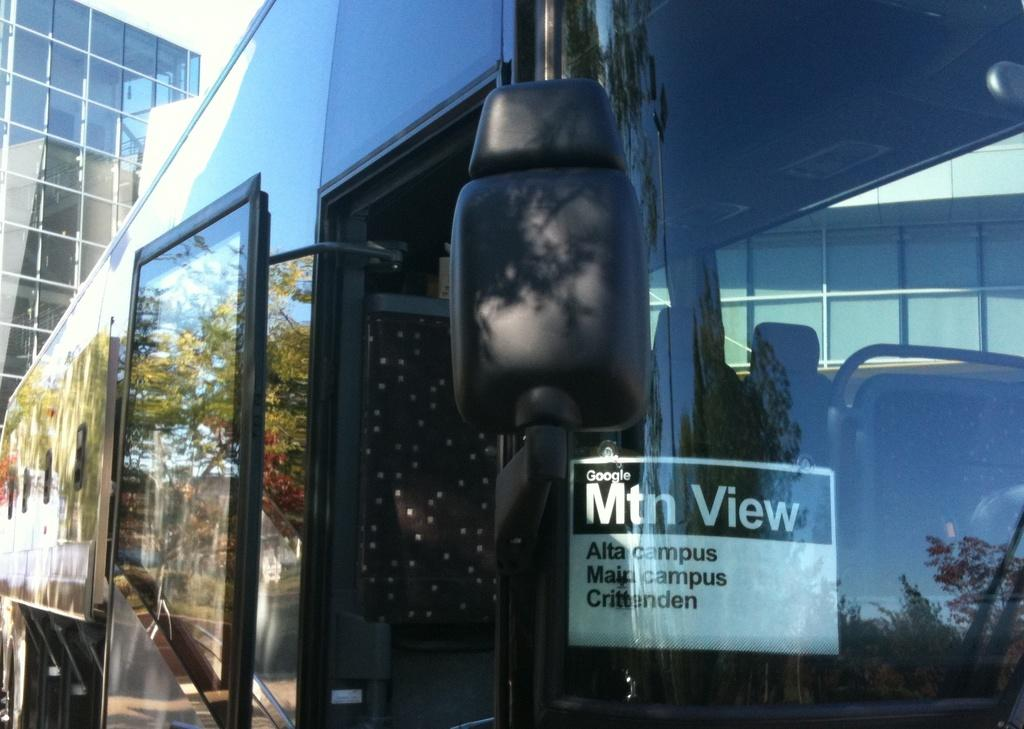What is the main subject of the image? The main subject of the image is a vehicle. What features can be seen on the vehicle? The vehicle has a door and a side view mirror. What else is present in the image besides the vehicle? There is a poster with text and a building in the background of the image. How many bombs can be seen in the image? There are no bombs present in the image. What type of cup is being used to drink coffee in the image? There is no cup or coffee present in the image. 